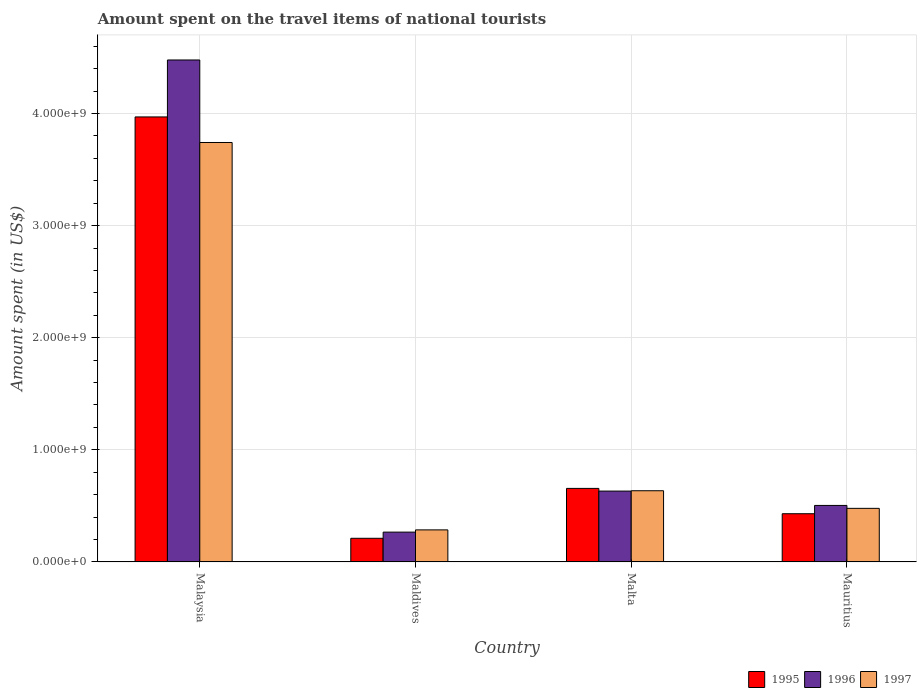How many bars are there on the 4th tick from the right?
Make the answer very short. 3. What is the label of the 3rd group of bars from the left?
Ensure brevity in your answer.  Malta. What is the amount spent on the travel items of national tourists in 1997 in Mauritius?
Make the answer very short. 4.78e+08. Across all countries, what is the maximum amount spent on the travel items of national tourists in 1996?
Your answer should be very brief. 4.48e+09. Across all countries, what is the minimum amount spent on the travel items of national tourists in 1995?
Keep it short and to the point. 2.11e+08. In which country was the amount spent on the travel items of national tourists in 1997 maximum?
Offer a terse response. Malaysia. In which country was the amount spent on the travel items of national tourists in 1997 minimum?
Your answer should be compact. Maldives. What is the total amount spent on the travel items of national tourists in 1996 in the graph?
Make the answer very short. 5.88e+09. What is the difference between the amount spent on the travel items of national tourists in 1996 in Maldives and that in Mauritius?
Give a very brief answer. -2.38e+08. What is the difference between the amount spent on the travel items of national tourists in 1995 in Maldives and the amount spent on the travel items of national tourists in 1996 in Malaysia?
Offer a terse response. -4.27e+09. What is the average amount spent on the travel items of national tourists in 1996 per country?
Make the answer very short. 1.47e+09. What is the difference between the amount spent on the travel items of national tourists of/in 1997 and amount spent on the travel items of national tourists of/in 1996 in Malaysia?
Your answer should be compact. -7.36e+08. In how many countries, is the amount spent on the travel items of national tourists in 1995 greater than 4000000000 US$?
Offer a very short reply. 0. What is the ratio of the amount spent on the travel items of national tourists in 1995 in Maldives to that in Malta?
Make the answer very short. 0.32. Is the difference between the amount spent on the travel items of national tourists in 1997 in Malaysia and Malta greater than the difference between the amount spent on the travel items of national tourists in 1996 in Malaysia and Malta?
Make the answer very short. No. What is the difference between the highest and the second highest amount spent on the travel items of national tourists in 1997?
Keep it short and to the point. 3.26e+09. What is the difference between the highest and the lowest amount spent on the travel items of national tourists in 1997?
Your answer should be compact. 3.46e+09. In how many countries, is the amount spent on the travel items of national tourists in 1995 greater than the average amount spent on the travel items of national tourists in 1995 taken over all countries?
Offer a terse response. 1. Is the sum of the amount spent on the travel items of national tourists in 1997 in Malaysia and Maldives greater than the maximum amount spent on the travel items of national tourists in 1995 across all countries?
Keep it short and to the point. Yes. Are all the bars in the graph horizontal?
Provide a succinct answer. No. What is the difference between two consecutive major ticks on the Y-axis?
Provide a succinct answer. 1.00e+09. Are the values on the major ticks of Y-axis written in scientific E-notation?
Offer a terse response. Yes. Does the graph contain any zero values?
Offer a very short reply. No. How are the legend labels stacked?
Your response must be concise. Horizontal. What is the title of the graph?
Offer a very short reply. Amount spent on the travel items of national tourists. What is the label or title of the Y-axis?
Provide a short and direct response. Amount spent (in US$). What is the Amount spent (in US$) of 1995 in Malaysia?
Provide a succinct answer. 3.97e+09. What is the Amount spent (in US$) in 1996 in Malaysia?
Make the answer very short. 4.48e+09. What is the Amount spent (in US$) in 1997 in Malaysia?
Your answer should be very brief. 3.74e+09. What is the Amount spent (in US$) in 1995 in Maldives?
Your response must be concise. 2.11e+08. What is the Amount spent (in US$) in 1996 in Maldives?
Offer a terse response. 2.66e+08. What is the Amount spent (in US$) of 1997 in Maldives?
Your answer should be compact. 2.86e+08. What is the Amount spent (in US$) of 1995 in Malta?
Provide a short and direct response. 6.56e+08. What is the Amount spent (in US$) in 1996 in Malta?
Your response must be concise. 6.32e+08. What is the Amount spent (in US$) in 1997 in Malta?
Your answer should be very brief. 6.35e+08. What is the Amount spent (in US$) of 1995 in Mauritius?
Ensure brevity in your answer.  4.30e+08. What is the Amount spent (in US$) of 1996 in Mauritius?
Make the answer very short. 5.04e+08. What is the Amount spent (in US$) of 1997 in Mauritius?
Your answer should be compact. 4.78e+08. Across all countries, what is the maximum Amount spent (in US$) in 1995?
Your answer should be very brief. 3.97e+09. Across all countries, what is the maximum Amount spent (in US$) in 1996?
Your answer should be compact. 4.48e+09. Across all countries, what is the maximum Amount spent (in US$) in 1997?
Offer a terse response. 3.74e+09. Across all countries, what is the minimum Amount spent (in US$) in 1995?
Provide a short and direct response. 2.11e+08. Across all countries, what is the minimum Amount spent (in US$) of 1996?
Offer a very short reply. 2.66e+08. Across all countries, what is the minimum Amount spent (in US$) in 1997?
Ensure brevity in your answer.  2.86e+08. What is the total Amount spent (in US$) of 1995 in the graph?
Provide a short and direct response. 5.27e+09. What is the total Amount spent (in US$) of 1996 in the graph?
Your answer should be very brief. 5.88e+09. What is the total Amount spent (in US$) in 1997 in the graph?
Offer a terse response. 5.14e+09. What is the difference between the Amount spent (in US$) of 1995 in Malaysia and that in Maldives?
Offer a terse response. 3.76e+09. What is the difference between the Amount spent (in US$) of 1996 in Malaysia and that in Maldives?
Keep it short and to the point. 4.21e+09. What is the difference between the Amount spent (in US$) of 1997 in Malaysia and that in Maldives?
Provide a short and direct response. 3.46e+09. What is the difference between the Amount spent (in US$) in 1995 in Malaysia and that in Malta?
Your answer should be very brief. 3.31e+09. What is the difference between the Amount spent (in US$) in 1996 in Malaysia and that in Malta?
Offer a terse response. 3.84e+09. What is the difference between the Amount spent (in US$) of 1997 in Malaysia and that in Malta?
Offer a terse response. 3.11e+09. What is the difference between the Amount spent (in US$) in 1995 in Malaysia and that in Mauritius?
Your answer should be very brief. 3.54e+09. What is the difference between the Amount spent (in US$) of 1996 in Malaysia and that in Mauritius?
Your response must be concise. 3.97e+09. What is the difference between the Amount spent (in US$) of 1997 in Malaysia and that in Mauritius?
Give a very brief answer. 3.26e+09. What is the difference between the Amount spent (in US$) in 1995 in Maldives and that in Malta?
Provide a short and direct response. -4.45e+08. What is the difference between the Amount spent (in US$) in 1996 in Maldives and that in Malta?
Keep it short and to the point. -3.66e+08. What is the difference between the Amount spent (in US$) of 1997 in Maldives and that in Malta?
Make the answer very short. -3.49e+08. What is the difference between the Amount spent (in US$) in 1995 in Maldives and that in Mauritius?
Your answer should be compact. -2.19e+08. What is the difference between the Amount spent (in US$) in 1996 in Maldives and that in Mauritius?
Make the answer very short. -2.38e+08. What is the difference between the Amount spent (in US$) in 1997 in Maldives and that in Mauritius?
Your answer should be very brief. -1.92e+08. What is the difference between the Amount spent (in US$) in 1995 in Malta and that in Mauritius?
Give a very brief answer. 2.26e+08. What is the difference between the Amount spent (in US$) in 1996 in Malta and that in Mauritius?
Your answer should be very brief. 1.28e+08. What is the difference between the Amount spent (in US$) of 1997 in Malta and that in Mauritius?
Provide a succinct answer. 1.57e+08. What is the difference between the Amount spent (in US$) of 1995 in Malaysia and the Amount spent (in US$) of 1996 in Maldives?
Provide a succinct answer. 3.70e+09. What is the difference between the Amount spent (in US$) of 1995 in Malaysia and the Amount spent (in US$) of 1997 in Maldives?
Offer a terse response. 3.68e+09. What is the difference between the Amount spent (in US$) of 1996 in Malaysia and the Amount spent (in US$) of 1997 in Maldives?
Provide a succinct answer. 4.19e+09. What is the difference between the Amount spent (in US$) of 1995 in Malaysia and the Amount spent (in US$) of 1996 in Malta?
Offer a terse response. 3.34e+09. What is the difference between the Amount spent (in US$) in 1995 in Malaysia and the Amount spent (in US$) in 1997 in Malta?
Your answer should be compact. 3.33e+09. What is the difference between the Amount spent (in US$) in 1996 in Malaysia and the Amount spent (in US$) in 1997 in Malta?
Your response must be concise. 3.84e+09. What is the difference between the Amount spent (in US$) in 1995 in Malaysia and the Amount spent (in US$) in 1996 in Mauritius?
Ensure brevity in your answer.  3.46e+09. What is the difference between the Amount spent (in US$) of 1995 in Malaysia and the Amount spent (in US$) of 1997 in Mauritius?
Make the answer very short. 3.49e+09. What is the difference between the Amount spent (in US$) in 1996 in Malaysia and the Amount spent (in US$) in 1997 in Mauritius?
Make the answer very short. 4.00e+09. What is the difference between the Amount spent (in US$) in 1995 in Maldives and the Amount spent (in US$) in 1996 in Malta?
Provide a succinct answer. -4.21e+08. What is the difference between the Amount spent (in US$) of 1995 in Maldives and the Amount spent (in US$) of 1997 in Malta?
Provide a short and direct response. -4.24e+08. What is the difference between the Amount spent (in US$) of 1996 in Maldives and the Amount spent (in US$) of 1997 in Malta?
Your response must be concise. -3.69e+08. What is the difference between the Amount spent (in US$) in 1995 in Maldives and the Amount spent (in US$) in 1996 in Mauritius?
Provide a short and direct response. -2.93e+08. What is the difference between the Amount spent (in US$) in 1995 in Maldives and the Amount spent (in US$) in 1997 in Mauritius?
Ensure brevity in your answer.  -2.67e+08. What is the difference between the Amount spent (in US$) in 1996 in Maldives and the Amount spent (in US$) in 1997 in Mauritius?
Your answer should be very brief. -2.12e+08. What is the difference between the Amount spent (in US$) of 1995 in Malta and the Amount spent (in US$) of 1996 in Mauritius?
Offer a very short reply. 1.52e+08. What is the difference between the Amount spent (in US$) of 1995 in Malta and the Amount spent (in US$) of 1997 in Mauritius?
Your response must be concise. 1.78e+08. What is the difference between the Amount spent (in US$) of 1996 in Malta and the Amount spent (in US$) of 1997 in Mauritius?
Your response must be concise. 1.54e+08. What is the average Amount spent (in US$) in 1995 per country?
Ensure brevity in your answer.  1.32e+09. What is the average Amount spent (in US$) in 1996 per country?
Keep it short and to the point. 1.47e+09. What is the average Amount spent (in US$) of 1997 per country?
Make the answer very short. 1.28e+09. What is the difference between the Amount spent (in US$) of 1995 and Amount spent (in US$) of 1996 in Malaysia?
Offer a terse response. -5.08e+08. What is the difference between the Amount spent (in US$) of 1995 and Amount spent (in US$) of 1997 in Malaysia?
Provide a short and direct response. 2.28e+08. What is the difference between the Amount spent (in US$) in 1996 and Amount spent (in US$) in 1997 in Malaysia?
Your response must be concise. 7.36e+08. What is the difference between the Amount spent (in US$) in 1995 and Amount spent (in US$) in 1996 in Maldives?
Your answer should be very brief. -5.50e+07. What is the difference between the Amount spent (in US$) in 1995 and Amount spent (in US$) in 1997 in Maldives?
Provide a short and direct response. -7.50e+07. What is the difference between the Amount spent (in US$) of 1996 and Amount spent (in US$) of 1997 in Maldives?
Your answer should be very brief. -2.00e+07. What is the difference between the Amount spent (in US$) of 1995 and Amount spent (in US$) of 1996 in Malta?
Offer a very short reply. 2.40e+07. What is the difference between the Amount spent (in US$) in 1995 and Amount spent (in US$) in 1997 in Malta?
Your answer should be very brief. 2.10e+07. What is the difference between the Amount spent (in US$) in 1996 and Amount spent (in US$) in 1997 in Malta?
Your response must be concise. -3.00e+06. What is the difference between the Amount spent (in US$) of 1995 and Amount spent (in US$) of 1996 in Mauritius?
Your answer should be compact. -7.40e+07. What is the difference between the Amount spent (in US$) in 1995 and Amount spent (in US$) in 1997 in Mauritius?
Your answer should be compact. -4.80e+07. What is the difference between the Amount spent (in US$) in 1996 and Amount spent (in US$) in 1997 in Mauritius?
Ensure brevity in your answer.  2.60e+07. What is the ratio of the Amount spent (in US$) of 1995 in Malaysia to that in Maldives?
Give a very brief answer. 18.81. What is the ratio of the Amount spent (in US$) of 1996 in Malaysia to that in Maldives?
Offer a very short reply. 16.83. What is the ratio of the Amount spent (in US$) of 1997 in Malaysia to that in Maldives?
Provide a short and direct response. 13.08. What is the ratio of the Amount spent (in US$) in 1995 in Malaysia to that in Malta?
Ensure brevity in your answer.  6.05. What is the ratio of the Amount spent (in US$) in 1996 in Malaysia to that in Malta?
Your response must be concise. 7.08. What is the ratio of the Amount spent (in US$) in 1997 in Malaysia to that in Malta?
Offer a very short reply. 5.89. What is the ratio of the Amount spent (in US$) in 1995 in Malaysia to that in Mauritius?
Your answer should be very brief. 9.23. What is the ratio of the Amount spent (in US$) of 1996 in Malaysia to that in Mauritius?
Your answer should be very brief. 8.88. What is the ratio of the Amount spent (in US$) of 1997 in Malaysia to that in Mauritius?
Give a very brief answer. 7.83. What is the ratio of the Amount spent (in US$) of 1995 in Maldives to that in Malta?
Ensure brevity in your answer.  0.32. What is the ratio of the Amount spent (in US$) in 1996 in Maldives to that in Malta?
Offer a terse response. 0.42. What is the ratio of the Amount spent (in US$) of 1997 in Maldives to that in Malta?
Your answer should be very brief. 0.45. What is the ratio of the Amount spent (in US$) of 1995 in Maldives to that in Mauritius?
Provide a short and direct response. 0.49. What is the ratio of the Amount spent (in US$) of 1996 in Maldives to that in Mauritius?
Provide a succinct answer. 0.53. What is the ratio of the Amount spent (in US$) in 1997 in Maldives to that in Mauritius?
Keep it short and to the point. 0.6. What is the ratio of the Amount spent (in US$) in 1995 in Malta to that in Mauritius?
Offer a terse response. 1.53. What is the ratio of the Amount spent (in US$) of 1996 in Malta to that in Mauritius?
Your answer should be compact. 1.25. What is the ratio of the Amount spent (in US$) in 1997 in Malta to that in Mauritius?
Provide a succinct answer. 1.33. What is the difference between the highest and the second highest Amount spent (in US$) of 1995?
Keep it short and to the point. 3.31e+09. What is the difference between the highest and the second highest Amount spent (in US$) in 1996?
Give a very brief answer. 3.84e+09. What is the difference between the highest and the second highest Amount spent (in US$) in 1997?
Offer a terse response. 3.11e+09. What is the difference between the highest and the lowest Amount spent (in US$) of 1995?
Offer a very short reply. 3.76e+09. What is the difference between the highest and the lowest Amount spent (in US$) of 1996?
Ensure brevity in your answer.  4.21e+09. What is the difference between the highest and the lowest Amount spent (in US$) in 1997?
Provide a succinct answer. 3.46e+09. 